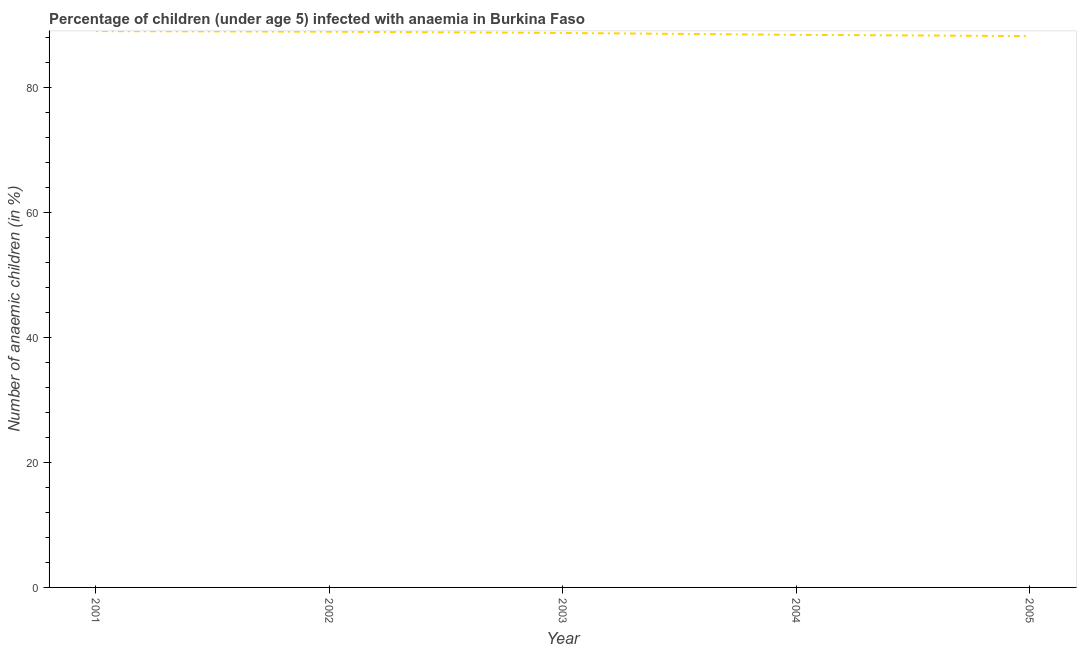What is the number of anaemic children in 2004?
Your answer should be very brief. 88.4. Across all years, what is the maximum number of anaemic children?
Provide a short and direct response. 89. Across all years, what is the minimum number of anaemic children?
Offer a terse response. 88.2. In which year was the number of anaemic children maximum?
Offer a very short reply. 2001. In which year was the number of anaemic children minimum?
Provide a succinct answer. 2005. What is the sum of the number of anaemic children?
Provide a succinct answer. 443.2. What is the difference between the number of anaemic children in 2002 and 2005?
Offer a very short reply. 0.7. What is the average number of anaemic children per year?
Offer a terse response. 88.64. What is the median number of anaemic children?
Provide a succinct answer. 88.7. In how many years, is the number of anaemic children greater than 64 %?
Ensure brevity in your answer.  5. What is the ratio of the number of anaemic children in 2001 to that in 2005?
Make the answer very short. 1.01. Is the difference between the number of anaemic children in 2002 and 2003 greater than the difference between any two years?
Ensure brevity in your answer.  No. What is the difference between the highest and the second highest number of anaemic children?
Provide a short and direct response. 0.1. Is the sum of the number of anaemic children in 2002 and 2004 greater than the maximum number of anaemic children across all years?
Your response must be concise. Yes. What is the difference between the highest and the lowest number of anaemic children?
Your answer should be very brief. 0.8. Does the number of anaemic children monotonically increase over the years?
Offer a very short reply. No. How many lines are there?
Offer a very short reply. 1. What is the title of the graph?
Your response must be concise. Percentage of children (under age 5) infected with anaemia in Burkina Faso. What is the label or title of the X-axis?
Give a very brief answer. Year. What is the label or title of the Y-axis?
Your response must be concise. Number of anaemic children (in %). What is the Number of anaemic children (in %) of 2001?
Provide a succinct answer. 89. What is the Number of anaemic children (in %) of 2002?
Give a very brief answer. 88.9. What is the Number of anaemic children (in %) in 2003?
Ensure brevity in your answer.  88.7. What is the Number of anaemic children (in %) in 2004?
Keep it short and to the point. 88.4. What is the Number of anaemic children (in %) of 2005?
Provide a short and direct response. 88.2. What is the difference between the Number of anaemic children (in %) in 2001 and 2005?
Provide a succinct answer. 0.8. What is the difference between the Number of anaemic children (in %) in 2002 and 2003?
Your answer should be very brief. 0.2. What is the difference between the Number of anaemic children (in %) in 2002 and 2004?
Ensure brevity in your answer.  0.5. What is the difference between the Number of anaemic children (in %) in 2003 and 2004?
Give a very brief answer. 0.3. What is the ratio of the Number of anaemic children (in %) in 2002 to that in 2005?
Offer a very short reply. 1.01. What is the ratio of the Number of anaemic children (in %) in 2003 to that in 2005?
Your response must be concise. 1.01. 